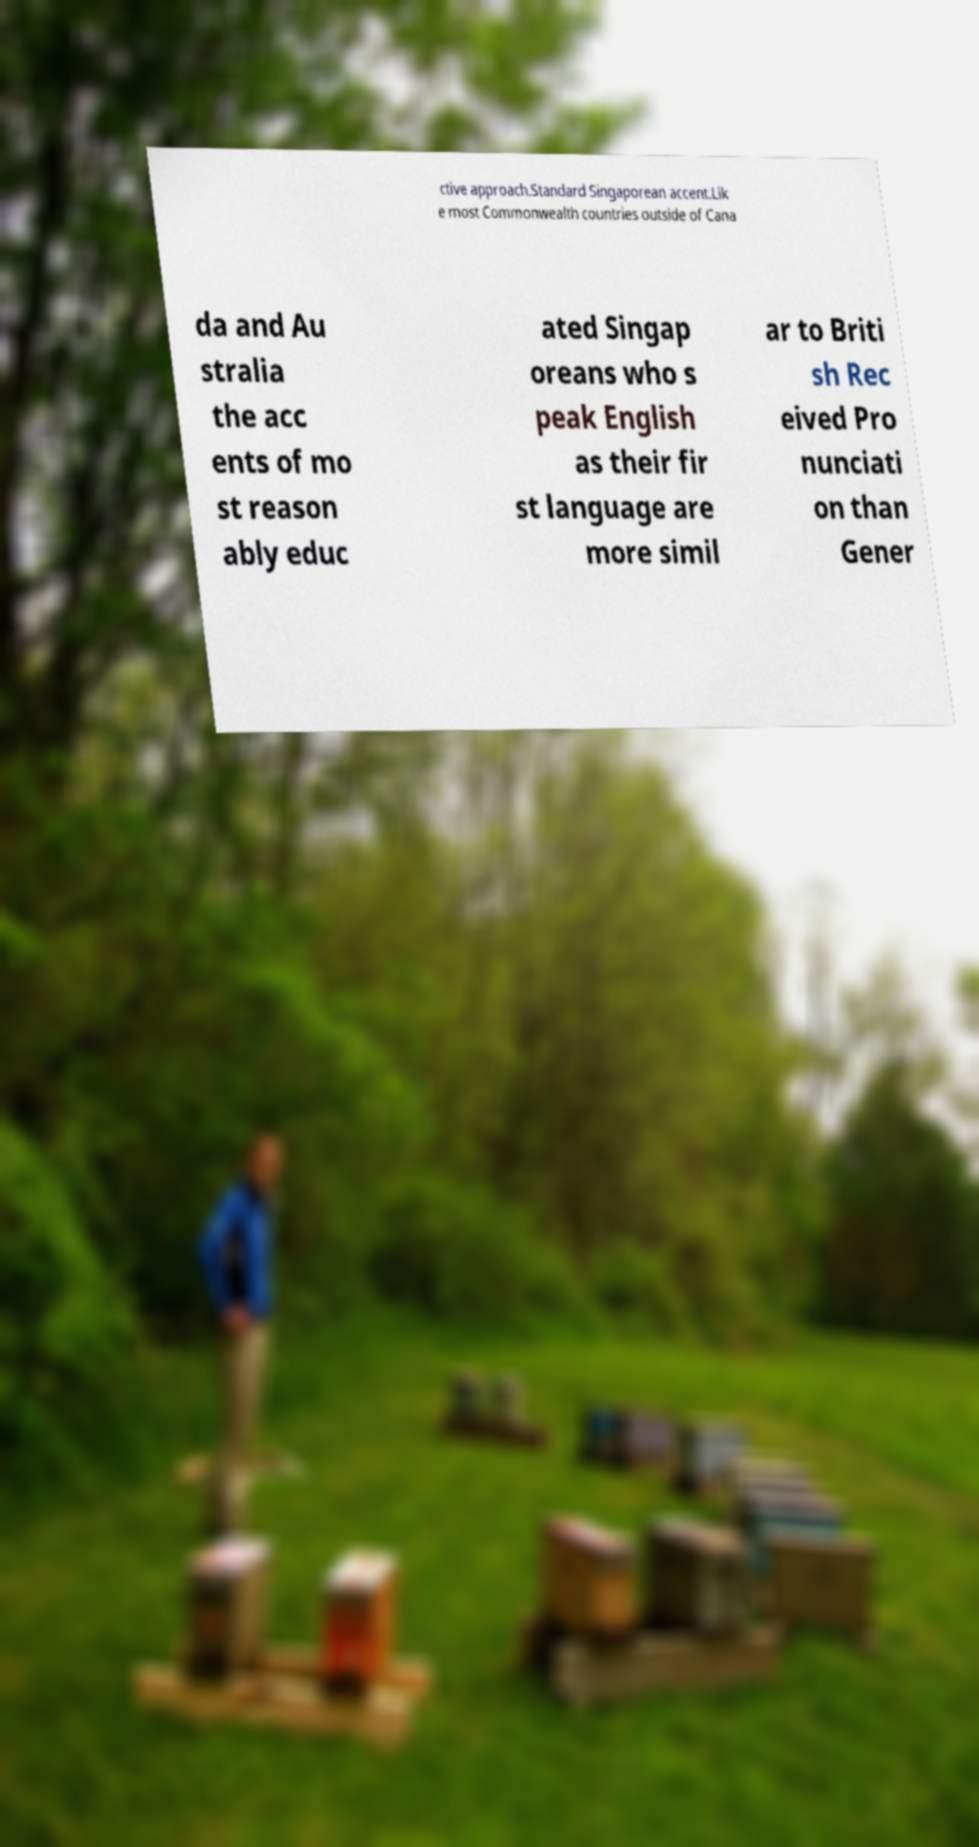I need the written content from this picture converted into text. Can you do that? ctive approach.Standard Singaporean accent.Lik e most Commonwealth countries outside of Cana da and Au stralia the acc ents of mo st reason ably educ ated Singap oreans who s peak English as their fir st language are more simil ar to Briti sh Rec eived Pro nunciati on than Gener 